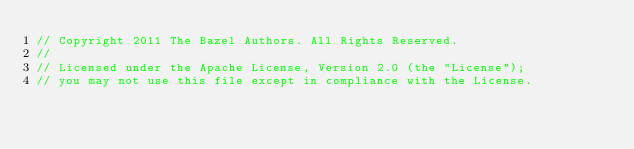<code> <loc_0><loc_0><loc_500><loc_500><_Java_>// Copyright 2011 The Bazel Authors. All Rights Reserved.
//
// Licensed under the Apache License, Version 2.0 (the "License");
// you may not use this file except in compliance with the License.</code> 